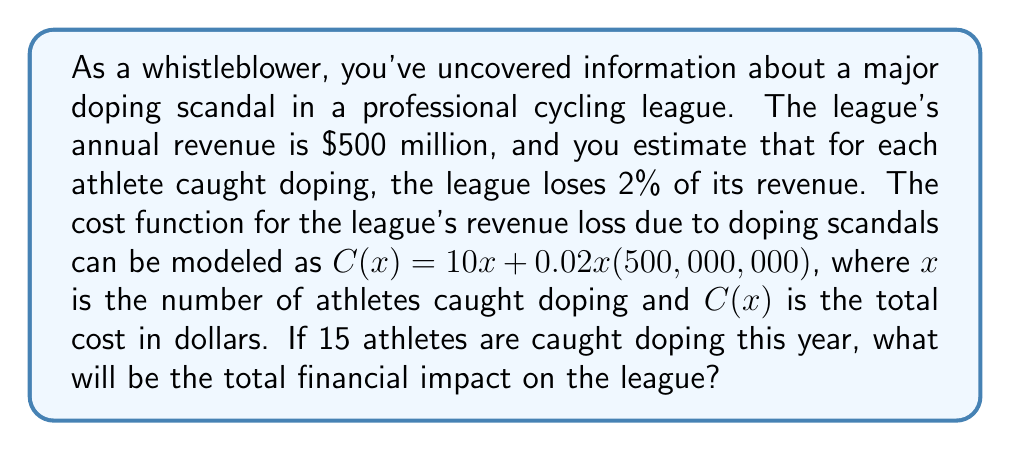Provide a solution to this math problem. Let's approach this step-by-step:

1) We're given the cost function:
   $$C(x) = 10x + 0.02x(500,000,000)$$

2) We need to calculate $C(15)$ as 15 athletes are caught doping:
   $$C(15) = 10(15) + 0.02(15)(500,000,000)$$

3) Let's simplify the first term:
   $$C(15) = 150 + 0.02(15)(500,000,000)$$

4) Now, let's simplify the second term:
   $$C(15) = 150 + 150,000,000$$

5) Finally, add the two terms:
   $$C(15) = 150,150,000$$

Therefore, the total financial impact on the league will be $150,150,000.
Answer: $150,150,000 